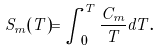Convert formula to latex. <formula><loc_0><loc_0><loc_500><loc_500>S _ { m } ( T ) = \int _ { 0 } ^ { T } \frac { C _ { m } } { T } d T .</formula> 